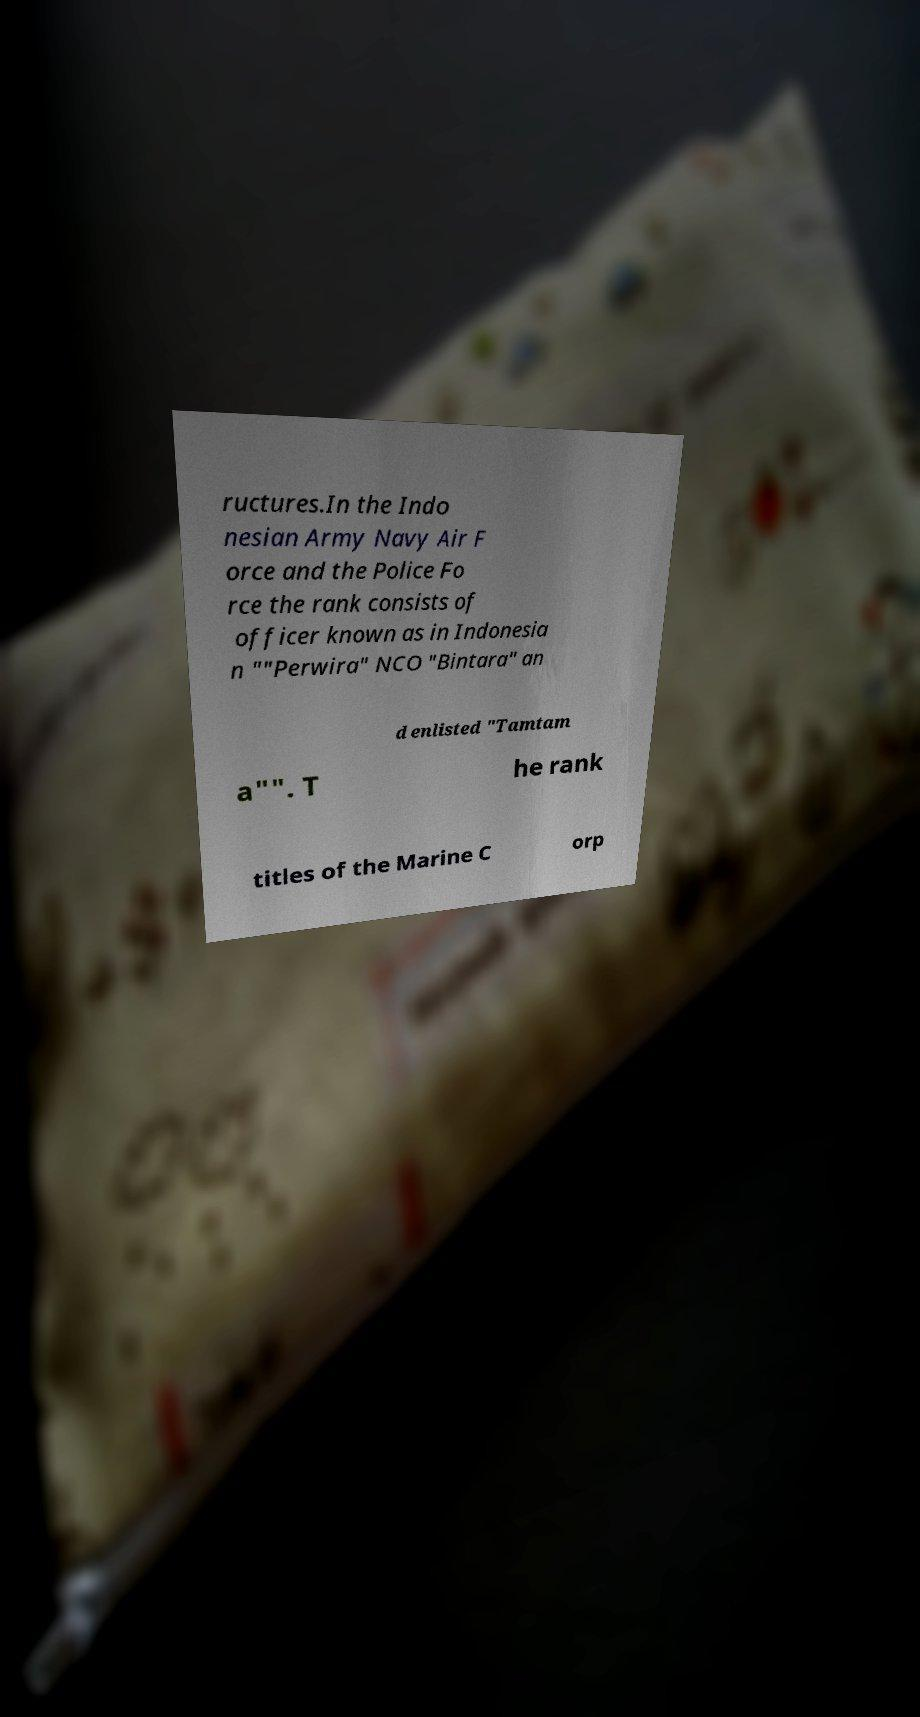Please read and relay the text visible in this image. What does it say? ructures.In the Indo nesian Army Navy Air F orce and the Police Fo rce the rank consists of officer known as in Indonesia n ""Perwira" NCO "Bintara" an d enlisted "Tamtam a"". T he rank titles of the Marine C orp 